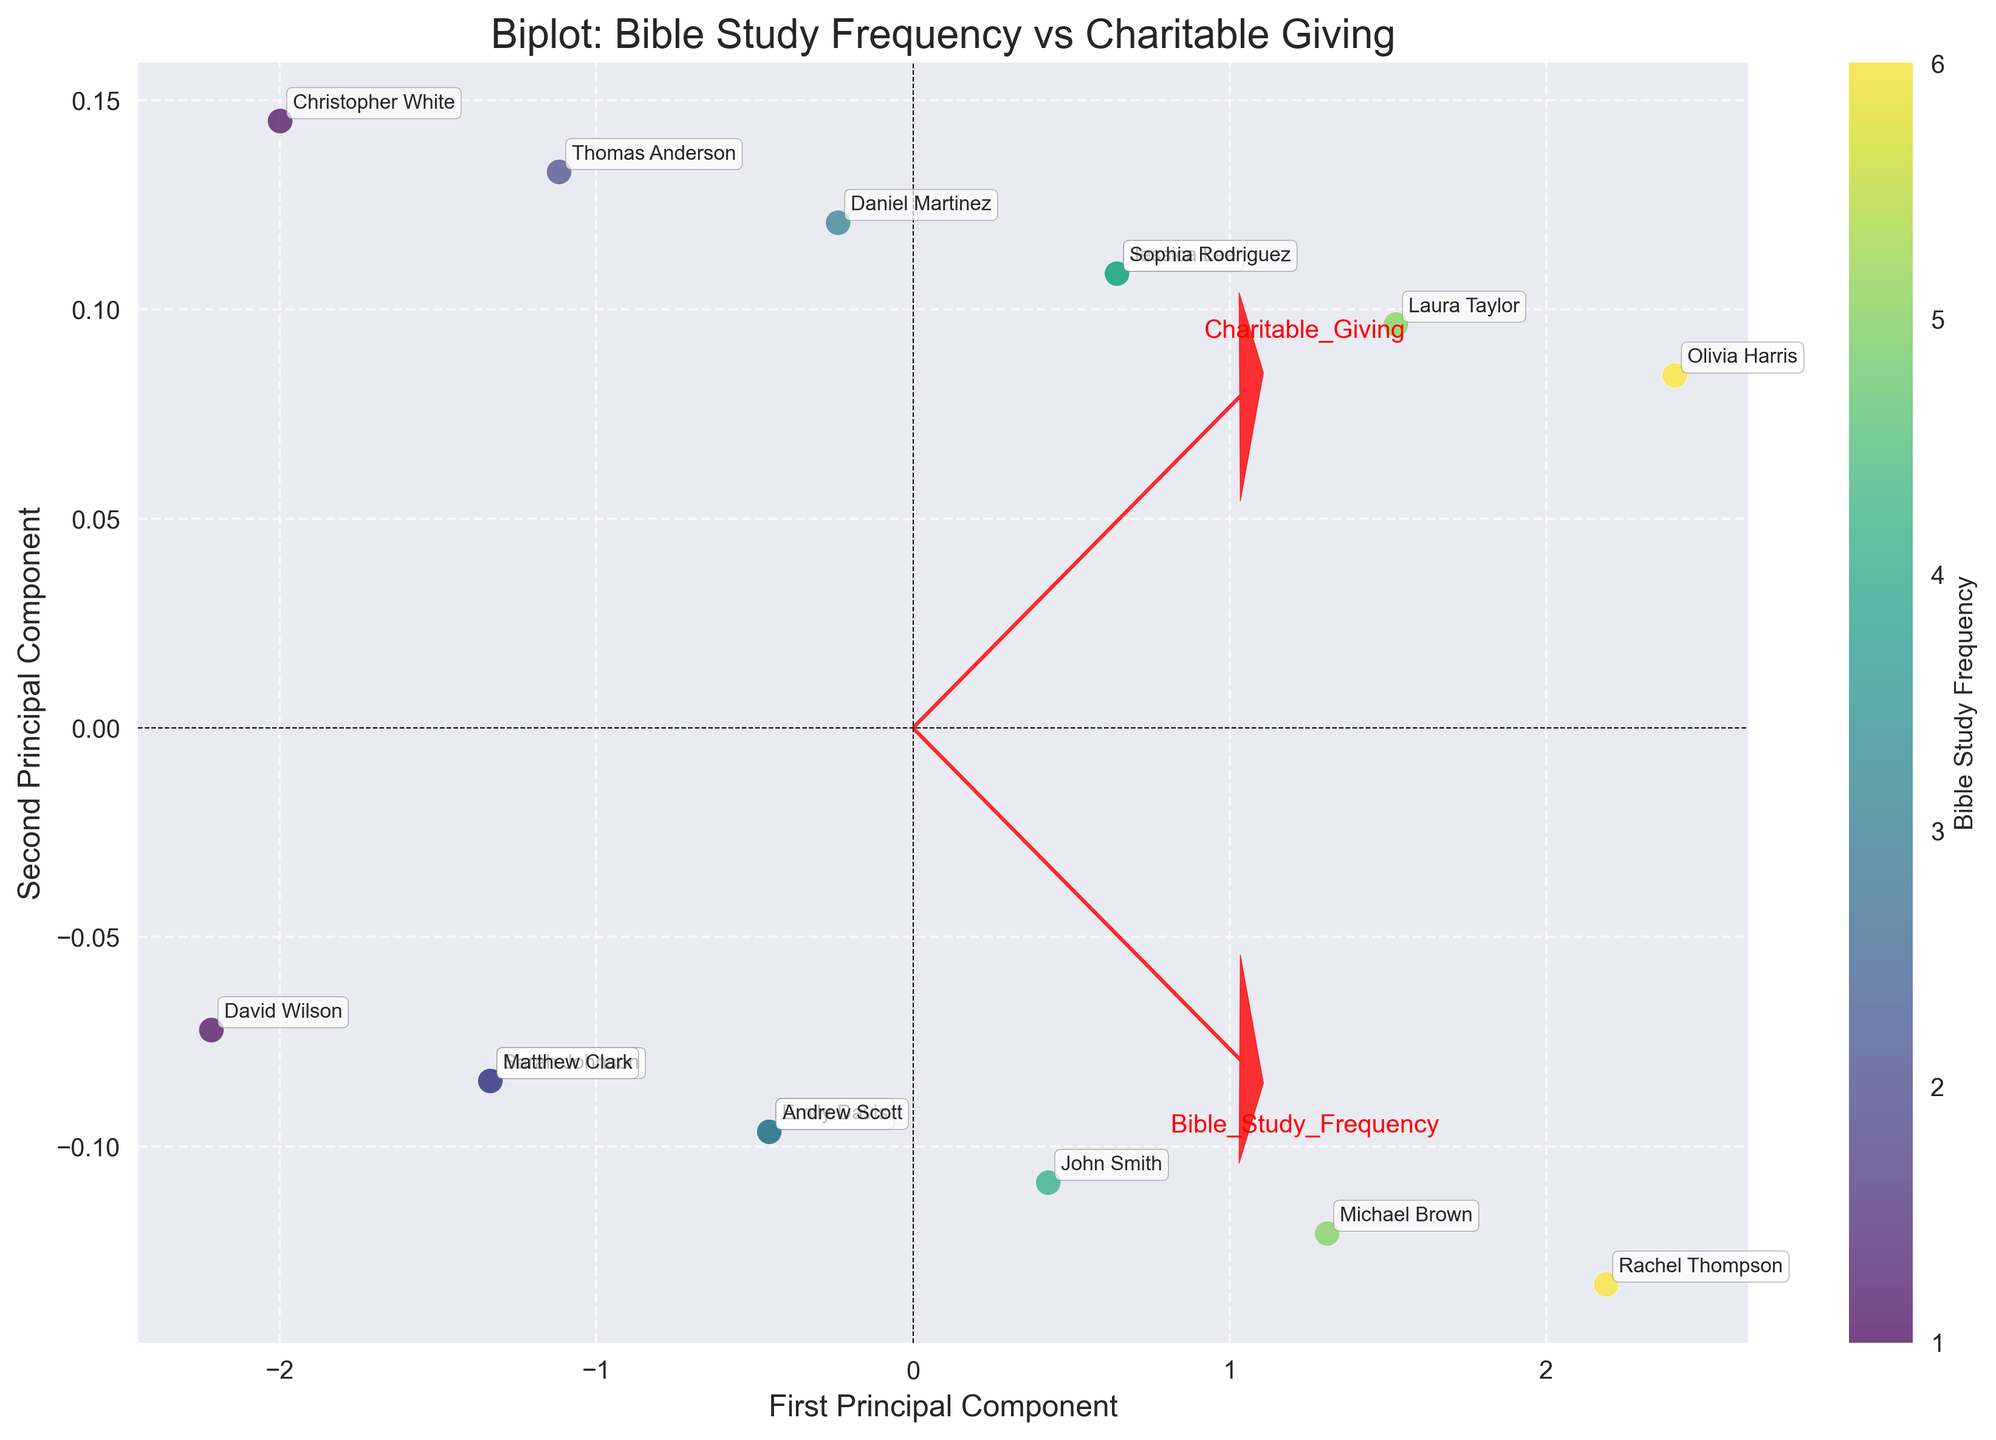How many members are represented in the plot? By counting the number of annotated names in the plot, we can determine the total number of members. Each point represents one member.
Answer: 15 What is the relationship between Bible Study Frequency and Charitable Giving? The loadings (red arrows) point towards the same direction for both Bible Study Frequency and Charitable Giving, indicating a positive correlation between these two variables. So, the more frequently members participate in Bible study, the more they tend to give charitably.
Answer: Positive correlation Which member has the highest frequency of Bible study? The plot uses color intensity to represent Bible study frequency. By looking for the member located near the point with the highest frequency (darkest color), we identify Olivia Harris as having the highest frequency.
Answer: Olivia Harris What are the axes labeled in the plot? The x-axis is labeled "First Principal Component" and the y-axis is labeled "Second Principal Component." These components represent the directions of maximum variance in the data after applying PCA.
Answer: First Principal Component, Second Principal Component Which member contributed the most charitably? By referring to the plot, the point farthest along the direction of the Charitable Giving arrow (the longest distance projected) represents the member who gave the most. This point corresponds to Olivia Harris.
Answer: Olivia Harris Is there any member who has both high Bible study frequency and high charitable giving? Members with high scores on both Bible Study Frequency and Charitable Giving would be located towards the upper-right side of the plot, near the direction of both loadings. Olivia Harris and Rachel Thompson fall into this category.
Answer: Yes Which member is least frequent in Bible study and also has low charitable giving? The member positioned closest to the origin in the direction opposite to both loadings will have the lowest Bible study frequency and charitable giving. This member is David Wilson.
Answer: David Wilson How are the scatter points visually distinct in terms of Bible study frequency? The scatter points are color-coded with varying shades from light to dark. Darker colors indicate higher Bible study frequency, while lighter colors indicate lower frequency.
Answer: Color shading How can you determine the explained variance of the principal components from this plot? This information isn't directly visible in the plot. We’d need additional context or data labels showing the explained variance percentage for both primary components.
Answer: Not directly visible 